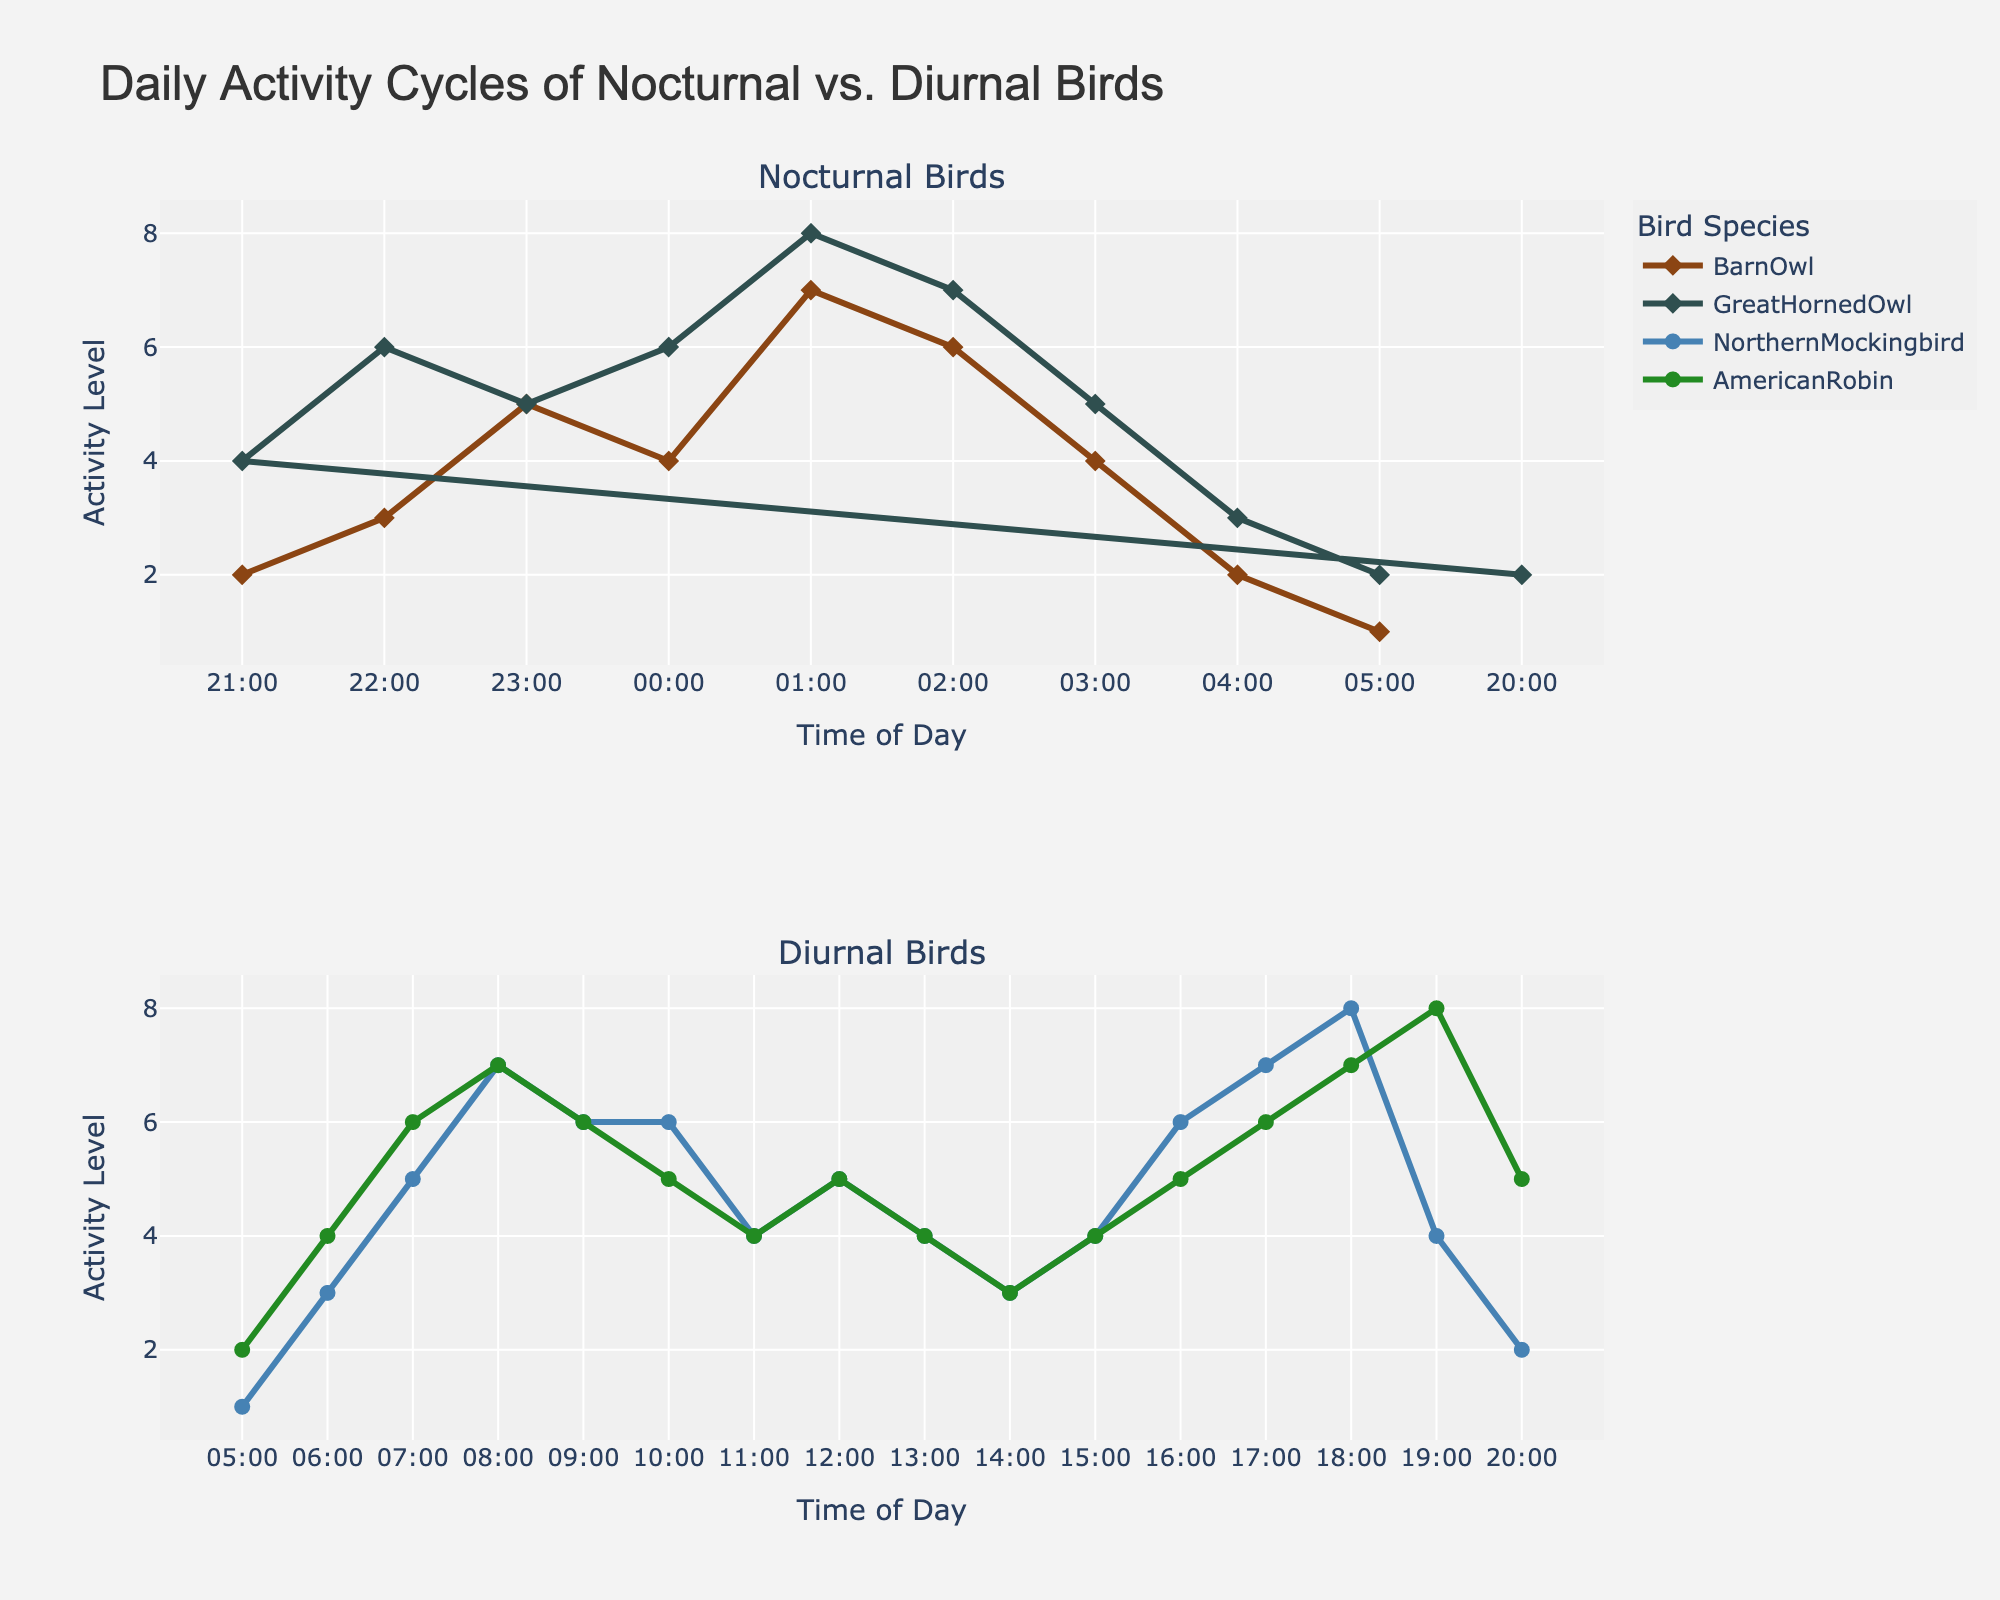What is the title of the plot? The title is usually found at the top of the plot and is set to describe or summarize the overall content of the figure. In this case, it reads "Daily Activity Cycles of Nocturnal vs. Diurnal Birds."
Answer: Daily Activity Cycles of Nocturnal vs. Diurnal Birds Which bird species shows the highest activity level at 01:00? At 01:00, the plot for nocturnal birds can be checked, and the species are Barn Owl and Great Horned Owl. The Great Horned Owl has the highest activity level at 01:00 compared to the Barn Owl.
Answer: Great Horned Owl At what time does the American Robin reach its peak activity level, and what is that level? In the subplot for diurnal birds, find the time of day marked by the highest point on the American Robin's activity curve. For this plot, it peaks at 19:00 with an activity level of 8.
Answer: 19:00, 8 Which bird species has a higher activity level at 06:00, Northern Mockingbird or American Robin? By examining the diurnal subplot at 06:00, we can compare the activity levels of the Northern Mockingbird and American Robin. The Northern Mockingbird has an activity level of 3, while the American Robin's activity level is 4. Hence, the American Robin has a higher activity level at this time.
Answer: American Robin Compare the peak activity levels of Barn Owl and Northern Mockingbird. Which one is higher, and by how much? Barn Owl reaches its peak activity level of 7 at 01:00. For Northern Mockingbird, the peak activity level is 8 at 18:00. The difference is 8 - 7 = 1.
Answer: Northern Mockingbird, 1 What time does the Great Horned Owl's activity drop to its minimum after reaching its peak? The Great Horned Owl's activity level peaks at 01:00 with a value of 8, and it drops to its minimum (2) at 05:00 thereafter.
Answer: 05:00 Do the diurnal birds show any activity after 20:00? By observing the diurnal subplot, we can see that after 20:00, both Northern Mockingbird and American Robin show no activity levels, indicating inactivity post 20:00.
Answer: No Which nocturnal bird has a higher activity level at 23:00? In the nocturnal subplot, check the activity levels for both Barn Owl and Great Horned Owl at 23:00. Barn Owl has an activity level of 5, while the Great Horned Owl also has an activity level of 5.
Answer: Both Between 00:00 and 05:00, which nocturnal bird shows a consistent decrease in activity level? By checking the nocturnal subplot from 00:00 to 05:00, Great Horned Owl has activity levels 6, 8, 7, 5, and 3 showing a decrease. Barn Owl also has a decrease but starts increasing again.
Answer: Great Horned Owl 